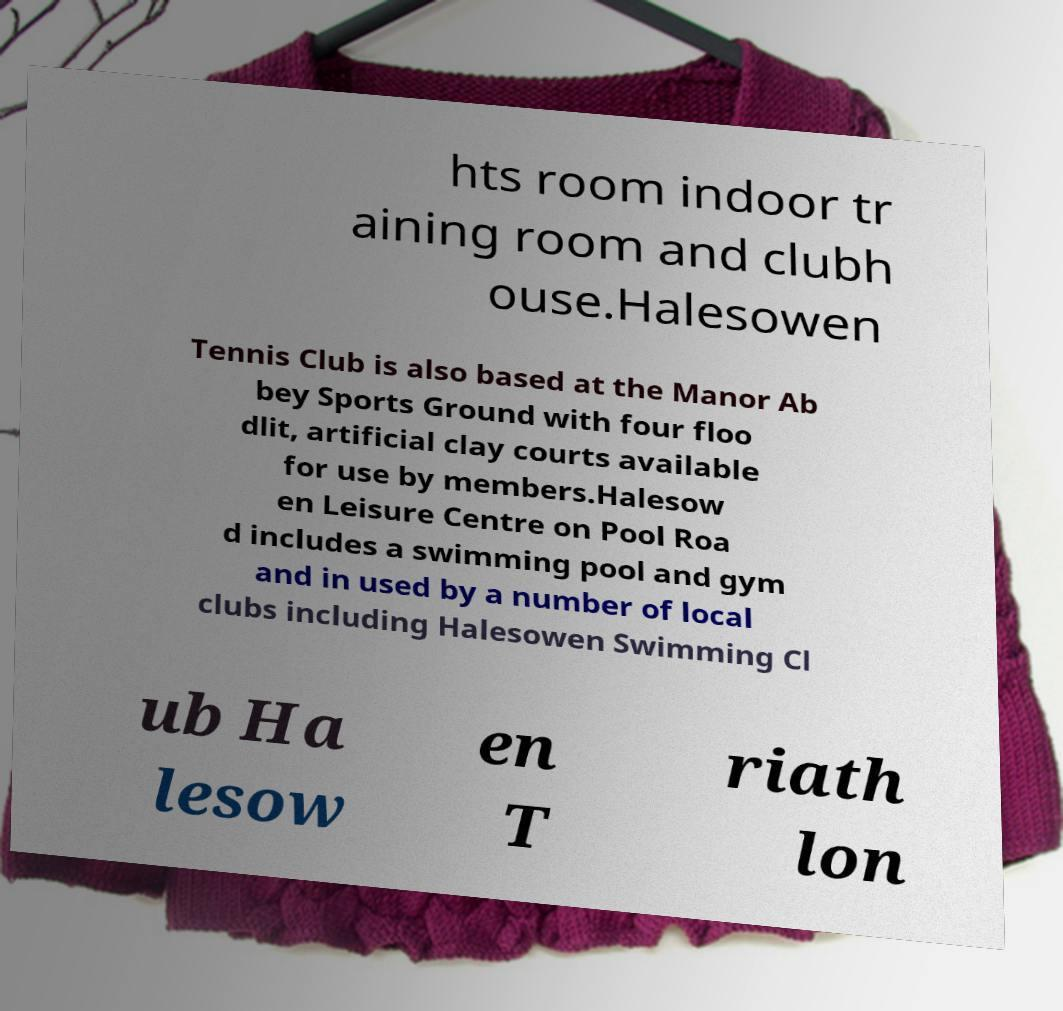There's text embedded in this image that I need extracted. Can you transcribe it verbatim? hts room indoor tr aining room and clubh ouse.Halesowen Tennis Club is also based at the Manor Ab bey Sports Ground with four floo dlit, artificial clay courts available for use by members.Halesow en Leisure Centre on Pool Roa d includes a swimming pool and gym and in used by a number of local clubs including Halesowen Swimming Cl ub Ha lesow en T riath lon 